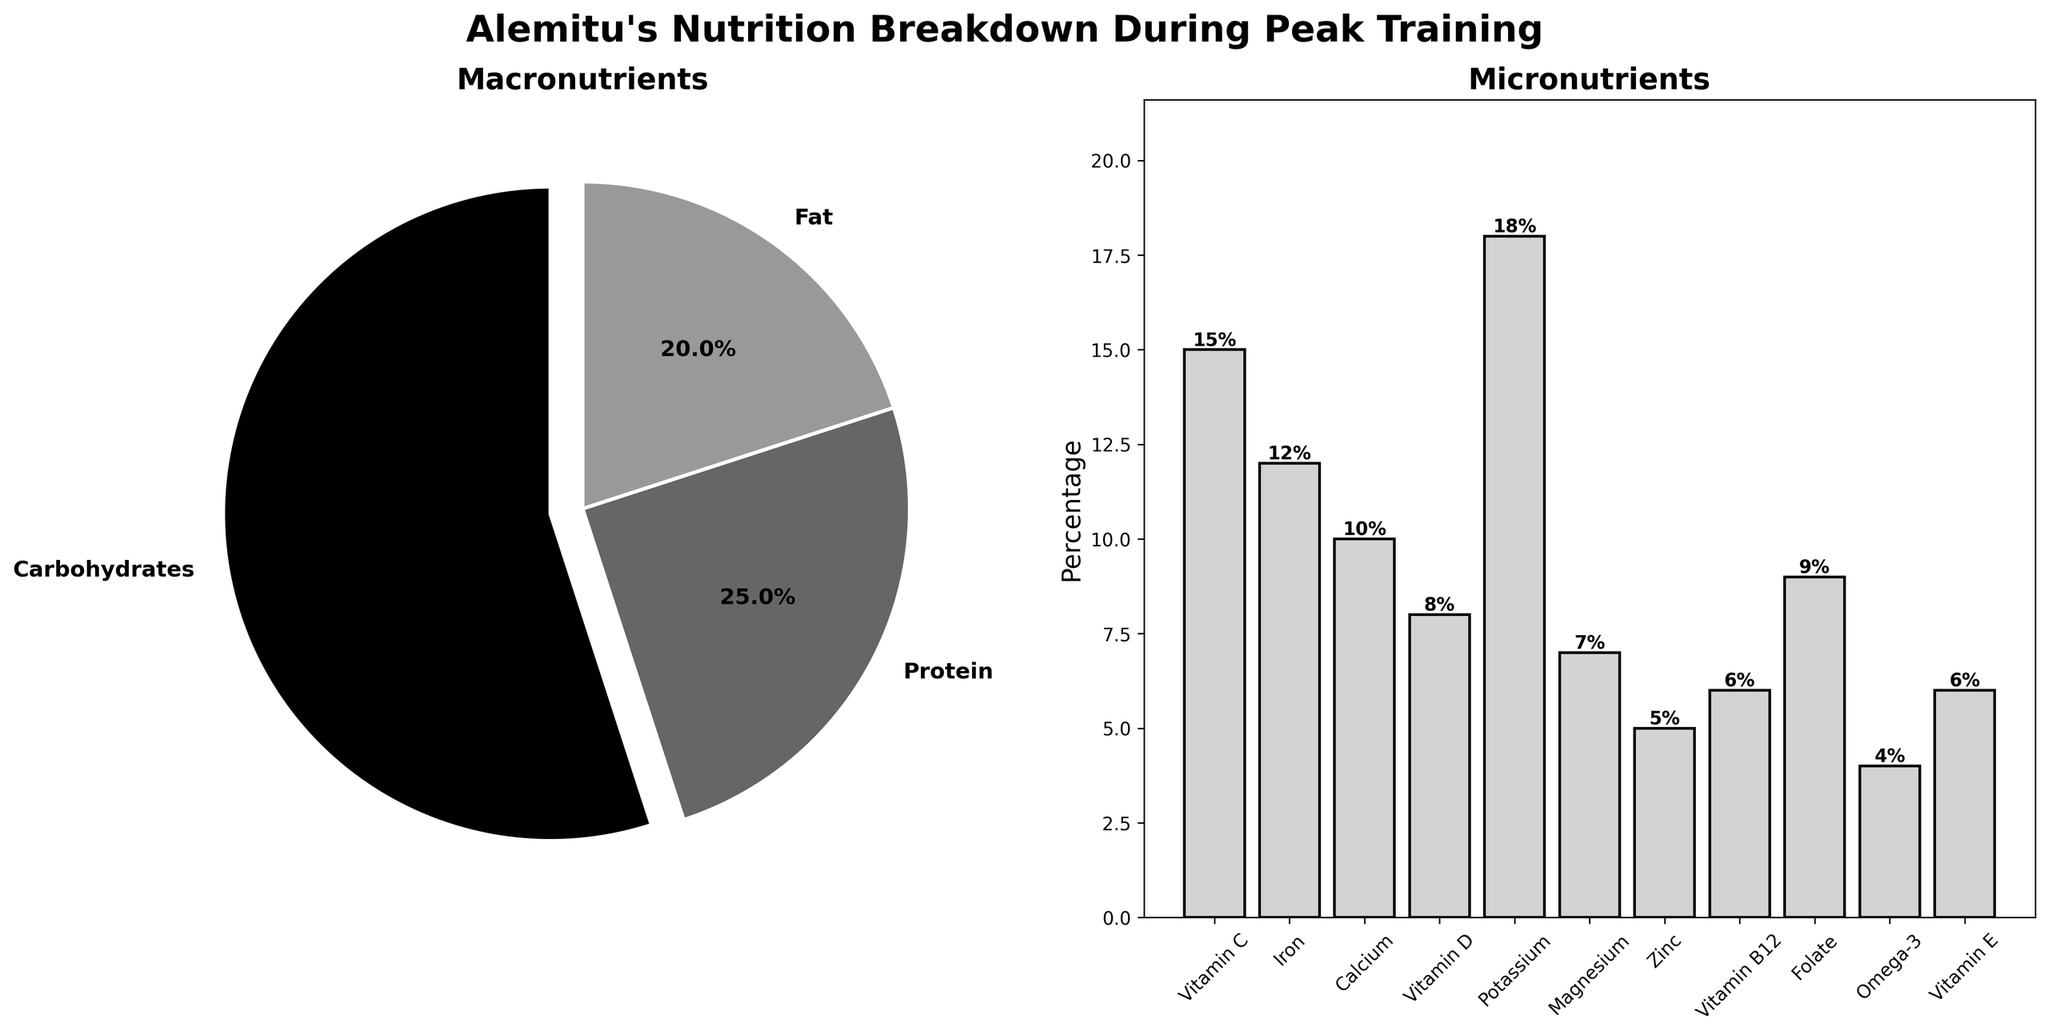what are the main categories shown in the figure? The figure features two main categories: "Macronutrients," depicted by a pie chart, and "Micronutrients," depicted by a bar chart.
Answer: Macronutrients and Micronutrients Which macronutrient has the highest percentage? The macronutrient pie chart shows carbohydrates with the largest slice. The label for carbohydrates indicates a percentage of 55%.
Answer: Carbohydrates What percentage of Alemitu's intake is made up of protein? In the macronutrient pie chart, the label next to protein indicates a percentage of 25%.
Answer: 25% How does the percentage of Omega-3 compare to Zinc? In the micronutrient bar chart, Omega-3 is shown at 4%, and Zinc is shown at 5%. Comparing these values, Omega-3's percentage is less than Zinc's.
Answer: Omega-3 is less than Zinc What is the combined percentage of Calcium, Magnesium, and Vitamin D? According to the micronutrient bar chart, Calcium is 10%, Magnesium is 7%, and Vitamin D is 8%. Adding them: 10% + 7% + 8% = 25%.
Answer: 25% Which micronutrient has the highest percentage, and what is its value? The micronutrient bar chart shows Potassium as the tallest bar, with a percentage label of 18%.
Answer: Potassium, 18% What is the smallest micronutrient percentage, and which nutrient does it correspond to? The bar chart for micronutrients shows Omega-3 with the smallest bar height and a percentage label of 4%.
Answer: Omega-3, 4% How does Alemitu's intake of iron compare to that of Vitamin C? The micronutrient bar chart shows Iron at 12% and Vitamin C at 15%. Iron has a lower percentage than Vitamin C.
Answer: Iron is lower than Vitamin C Which macronutrient has the smallest contribution, and what percentage is it? Within the macronutrient pie chart, Fat is the smallest slice with a percentage of 20%.
Answer: Fat, 20% What is the total percentage of all the macronutrients combined? Summing up the macronutrients from the pie chart: Carbohydrates (55%), Protein (25%), and Fat (20%) equals 55% + 25% + 20% = 100%.
Answer: 100% 